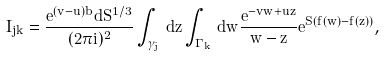<formula> <loc_0><loc_0><loc_500><loc_500>I _ { j k } = \frac { e ^ { ( v - u ) b } d S ^ { 1 / 3 } } { ( 2 \pi i ) ^ { 2 } } \int _ { \gamma _ { j } } \, d z \int _ { \Gamma _ { k } } \, d w \frac { e ^ { - v w + u z } } { w - z } e ^ { S ( f ( w ) - f ( z ) ) } ,</formula> 